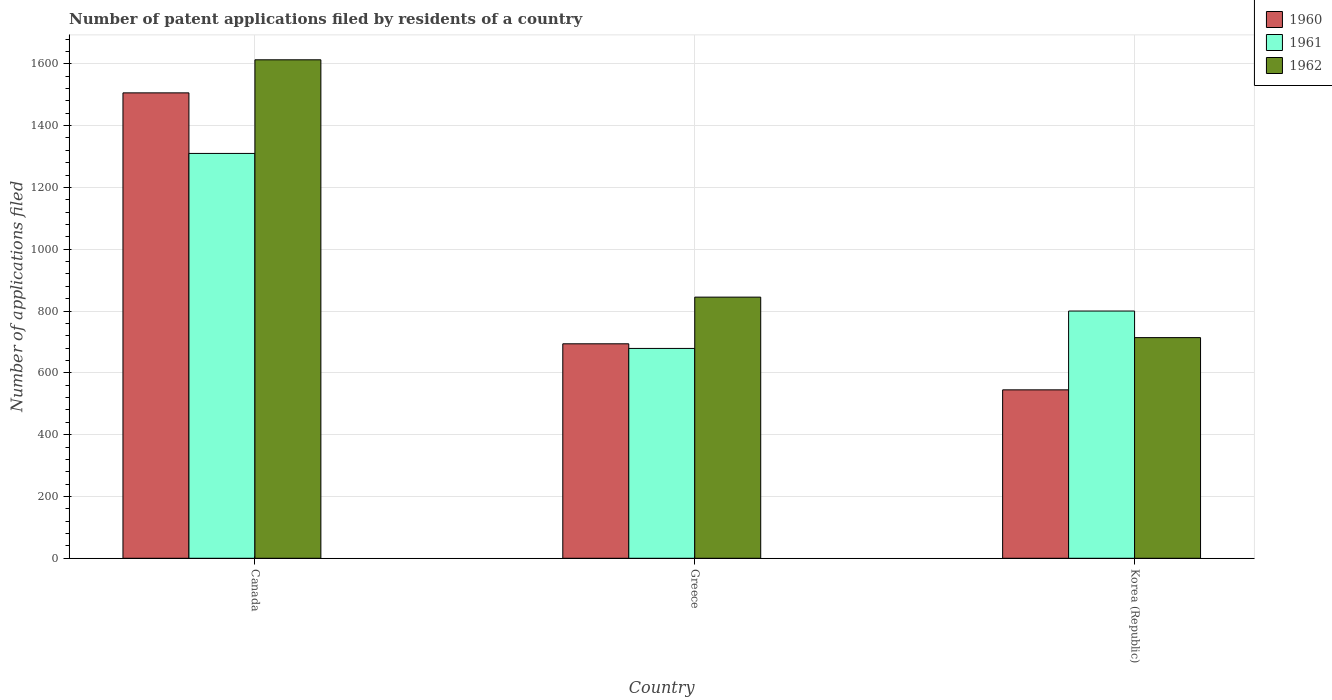How many different coloured bars are there?
Keep it short and to the point. 3. How many groups of bars are there?
Your answer should be compact. 3. What is the number of applications filed in 1961 in Canada?
Ensure brevity in your answer.  1310. Across all countries, what is the maximum number of applications filed in 1961?
Give a very brief answer. 1310. Across all countries, what is the minimum number of applications filed in 1962?
Your answer should be very brief. 714. In which country was the number of applications filed in 1960 minimum?
Offer a very short reply. Korea (Republic). What is the total number of applications filed in 1961 in the graph?
Your response must be concise. 2789. What is the difference between the number of applications filed in 1961 in Greece and that in Korea (Republic)?
Your answer should be compact. -121. What is the difference between the number of applications filed in 1962 in Canada and the number of applications filed in 1961 in Greece?
Your response must be concise. 934. What is the average number of applications filed in 1962 per country?
Offer a very short reply. 1057.33. What is the difference between the number of applications filed of/in 1961 and number of applications filed of/in 1962 in Canada?
Your answer should be compact. -303. In how many countries, is the number of applications filed in 1960 greater than 1560?
Offer a terse response. 0. What is the ratio of the number of applications filed in 1962 in Canada to that in Greece?
Make the answer very short. 1.91. Is the number of applications filed in 1960 in Canada less than that in Greece?
Your answer should be compact. No. What is the difference between the highest and the second highest number of applications filed in 1961?
Offer a very short reply. -510. What is the difference between the highest and the lowest number of applications filed in 1960?
Provide a succinct answer. 961. In how many countries, is the number of applications filed in 1962 greater than the average number of applications filed in 1962 taken over all countries?
Your answer should be very brief. 1. Is the sum of the number of applications filed in 1962 in Canada and Korea (Republic) greater than the maximum number of applications filed in 1961 across all countries?
Make the answer very short. Yes. What does the 1st bar from the left in Canada represents?
Ensure brevity in your answer.  1960. What does the 1st bar from the right in Korea (Republic) represents?
Offer a very short reply. 1962. Is it the case that in every country, the sum of the number of applications filed in 1961 and number of applications filed in 1960 is greater than the number of applications filed in 1962?
Give a very brief answer. Yes. How many bars are there?
Keep it short and to the point. 9. Are all the bars in the graph horizontal?
Offer a very short reply. No. How many countries are there in the graph?
Make the answer very short. 3. What is the difference between two consecutive major ticks on the Y-axis?
Ensure brevity in your answer.  200. Does the graph contain any zero values?
Your answer should be compact. No. Does the graph contain grids?
Provide a short and direct response. Yes. How many legend labels are there?
Your response must be concise. 3. How are the legend labels stacked?
Offer a very short reply. Vertical. What is the title of the graph?
Your response must be concise. Number of patent applications filed by residents of a country. What is the label or title of the Y-axis?
Provide a short and direct response. Number of applications filed. What is the Number of applications filed of 1960 in Canada?
Offer a very short reply. 1506. What is the Number of applications filed in 1961 in Canada?
Your answer should be very brief. 1310. What is the Number of applications filed of 1962 in Canada?
Your response must be concise. 1613. What is the Number of applications filed of 1960 in Greece?
Keep it short and to the point. 694. What is the Number of applications filed in 1961 in Greece?
Offer a terse response. 679. What is the Number of applications filed in 1962 in Greece?
Provide a succinct answer. 845. What is the Number of applications filed in 1960 in Korea (Republic)?
Give a very brief answer. 545. What is the Number of applications filed of 1961 in Korea (Republic)?
Make the answer very short. 800. What is the Number of applications filed in 1962 in Korea (Republic)?
Provide a succinct answer. 714. Across all countries, what is the maximum Number of applications filed of 1960?
Provide a short and direct response. 1506. Across all countries, what is the maximum Number of applications filed of 1961?
Provide a succinct answer. 1310. Across all countries, what is the maximum Number of applications filed in 1962?
Your answer should be very brief. 1613. Across all countries, what is the minimum Number of applications filed in 1960?
Give a very brief answer. 545. Across all countries, what is the minimum Number of applications filed in 1961?
Provide a short and direct response. 679. Across all countries, what is the minimum Number of applications filed in 1962?
Make the answer very short. 714. What is the total Number of applications filed of 1960 in the graph?
Offer a terse response. 2745. What is the total Number of applications filed of 1961 in the graph?
Offer a very short reply. 2789. What is the total Number of applications filed in 1962 in the graph?
Provide a short and direct response. 3172. What is the difference between the Number of applications filed of 1960 in Canada and that in Greece?
Your answer should be compact. 812. What is the difference between the Number of applications filed in 1961 in Canada and that in Greece?
Your answer should be compact. 631. What is the difference between the Number of applications filed of 1962 in Canada and that in Greece?
Offer a very short reply. 768. What is the difference between the Number of applications filed in 1960 in Canada and that in Korea (Republic)?
Your response must be concise. 961. What is the difference between the Number of applications filed in 1961 in Canada and that in Korea (Republic)?
Your answer should be compact. 510. What is the difference between the Number of applications filed of 1962 in Canada and that in Korea (Republic)?
Provide a succinct answer. 899. What is the difference between the Number of applications filed in 1960 in Greece and that in Korea (Republic)?
Ensure brevity in your answer.  149. What is the difference between the Number of applications filed in 1961 in Greece and that in Korea (Republic)?
Provide a short and direct response. -121. What is the difference between the Number of applications filed of 1962 in Greece and that in Korea (Republic)?
Offer a terse response. 131. What is the difference between the Number of applications filed of 1960 in Canada and the Number of applications filed of 1961 in Greece?
Offer a very short reply. 827. What is the difference between the Number of applications filed of 1960 in Canada and the Number of applications filed of 1962 in Greece?
Your answer should be very brief. 661. What is the difference between the Number of applications filed of 1961 in Canada and the Number of applications filed of 1962 in Greece?
Keep it short and to the point. 465. What is the difference between the Number of applications filed in 1960 in Canada and the Number of applications filed in 1961 in Korea (Republic)?
Give a very brief answer. 706. What is the difference between the Number of applications filed of 1960 in Canada and the Number of applications filed of 1962 in Korea (Republic)?
Keep it short and to the point. 792. What is the difference between the Number of applications filed in 1961 in Canada and the Number of applications filed in 1962 in Korea (Republic)?
Provide a short and direct response. 596. What is the difference between the Number of applications filed of 1960 in Greece and the Number of applications filed of 1961 in Korea (Republic)?
Provide a succinct answer. -106. What is the difference between the Number of applications filed of 1960 in Greece and the Number of applications filed of 1962 in Korea (Republic)?
Make the answer very short. -20. What is the difference between the Number of applications filed in 1961 in Greece and the Number of applications filed in 1962 in Korea (Republic)?
Your response must be concise. -35. What is the average Number of applications filed of 1960 per country?
Offer a terse response. 915. What is the average Number of applications filed of 1961 per country?
Your response must be concise. 929.67. What is the average Number of applications filed of 1962 per country?
Keep it short and to the point. 1057.33. What is the difference between the Number of applications filed in 1960 and Number of applications filed in 1961 in Canada?
Your response must be concise. 196. What is the difference between the Number of applications filed of 1960 and Number of applications filed of 1962 in Canada?
Your answer should be compact. -107. What is the difference between the Number of applications filed in 1961 and Number of applications filed in 1962 in Canada?
Provide a short and direct response. -303. What is the difference between the Number of applications filed of 1960 and Number of applications filed of 1962 in Greece?
Your answer should be compact. -151. What is the difference between the Number of applications filed of 1961 and Number of applications filed of 1962 in Greece?
Provide a short and direct response. -166. What is the difference between the Number of applications filed in 1960 and Number of applications filed in 1961 in Korea (Republic)?
Your answer should be very brief. -255. What is the difference between the Number of applications filed in 1960 and Number of applications filed in 1962 in Korea (Republic)?
Your answer should be very brief. -169. What is the ratio of the Number of applications filed of 1960 in Canada to that in Greece?
Offer a terse response. 2.17. What is the ratio of the Number of applications filed of 1961 in Canada to that in Greece?
Give a very brief answer. 1.93. What is the ratio of the Number of applications filed in 1962 in Canada to that in Greece?
Your response must be concise. 1.91. What is the ratio of the Number of applications filed of 1960 in Canada to that in Korea (Republic)?
Keep it short and to the point. 2.76. What is the ratio of the Number of applications filed of 1961 in Canada to that in Korea (Republic)?
Keep it short and to the point. 1.64. What is the ratio of the Number of applications filed of 1962 in Canada to that in Korea (Republic)?
Provide a succinct answer. 2.26. What is the ratio of the Number of applications filed in 1960 in Greece to that in Korea (Republic)?
Provide a short and direct response. 1.27. What is the ratio of the Number of applications filed in 1961 in Greece to that in Korea (Republic)?
Offer a terse response. 0.85. What is the ratio of the Number of applications filed in 1962 in Greece to that in Korea (Republic)?
Your response must be concise. 1.18. What is the difference between the highest and the second highest Number of applications filed in 1960?
Your answer should be very brief. 812. What is the difference between the highest and the second highest Number of applications filed in 1961?
Provide a succinct answer. 510. What is the difference between the highest and the second highest Number of applications filed of 1962?
Your answer should be very brief. 768. What is the difference between the highest and the lowest Number of applications filed in 1960?
Your answer should be very brief. 961. What is the difference between the highest and the lowest Number of applications filed in 1961?
Your answer should be very brief. 631. What is the difference between the highest and the lowest Number of applications filed of 1962?
Your response must be concise. 899. 